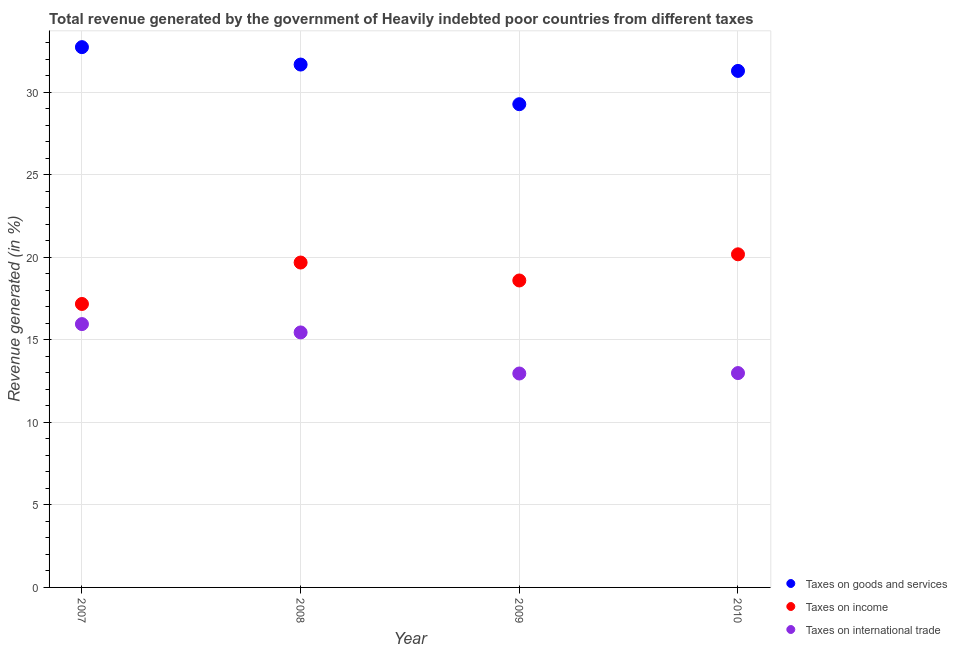Is the number of dotlines equal to the number of legend labels?
Your response must be concise. Yes. What is the percentage of revenue generated by taxes on goods and services in 2007?
Provide a succinct answer. 32.74. Across all years, what is the maximum percentage of revenue generated by taxes on goods and services?
Your response must be concise. 32.74. Across all years, what is the minimum percentage of revenue generated by taxes on goods and services?
Offer a very short reply. 29.28. What is the total percentage of revenue generated by tax on international trade in the graph?
Keep it short and to the point. 57.36. What is the difference between the percentage of revenue generated by tax on international trade in 2008 and that in 2009?
Keep it short and to the point. 2.49. What is the difference between the percentage of revenue generated by tax on international trade in 2010 and the percentage of revenue generated by taxes on goods and services in 2009?
Provide a short and direct response. -16.29. What is the average percentage of revenue generated by taxes on income per year?
Give a very brief answer. 18.91. In the year 2008, what is the difference between the percentage of revenue generated by taxes on goods and services and percentage of revenue generated by tax on international trade?
Your answer should be very brief. 16.23. What is the ratio of the percentage of revenue generated by tax on international trade in 2008 to that in 2010?
Keep it short and to the point. 1.19. What is the difference between the highest and the second highest percentage of revenue generated by tax on international trade?
Offer a terse response. 0.51. What is the difference between the highest and the lowest percentage of revenue generated by taxes on income?
Your answer should be very brief. 3.01. Is it the case that in every year, the sum of the percentage of revenue generated by taxes on goods and services and percentage of revenue generated by taxes on income is greater than the percentage of revenue generated by tax on international trade?
Ensure brevity in your answer.  Yes. Is the percentage of revenue generated by tax on international trade strictly greater than the percentage of revenue generated by taxes on income over the years?
Offer a terse response. No. Is the percentage of revenue generated by taxes on goods and services strictly less than the percentage of revenue generated by tax on international trade over the years?
Your answer should be compact. No. How many dotlines are there?
Ensure brevity in your answer.  3. How many years are there in the graph?
Offer a very short reply. 4. What is the difference between two consecutive major ticks on the Y-axis?
Offer a terse response. 5. Does the graph contain any zero values?
Keep it short and to the point. No. Does the graph contain grids?
Give a very brief answer. Yes. Where does the legend appear in the graph?
Offer a terse response. Bottom right. How are the legend labels stacked?
Ensure brevity in your answer.  Vertical. What is the title of the graph?
Make the answer very short. Total revenue generated by the government of Heavily indebted poor countries from different taxes. Does "Ages 65 and above" appear as one of the legend labels in the graph?
Provide a succinct answer. No. What is the label or title of the Y-axis?
Offer a very short reply. Revenue generated (in %). What is the Revenue generated (in %) of Taxes on goods and services in 2007?
Your answer should be compact. 32.74. What is the Revenue generated (in %) of Taxes on income in 2007?
Keep it short and to the point. 17.18. What is the Revenue generated (in %) in Taxes on international trade in 2007?
Offer a very short reply. 15.96. What is the Revenue generated (in %) of Taxes on goods and services in 2008?
Ensure brevity in your answer.  31.68. What is the Revenue generated (in %) of Taxes on income in 2008?
Your answer should be very brief. 19.69. What is the Revenue generated (in %) of Taxes on international trade in 2008?
Ensure brevity in your answer.  15.45. What is the Revenue generated (in %) in Taxes on goods and services in 2009?
Offer a terse response. 29.28. What is the Revenue generated (in %) in Taxes on income in 2009?
Offer a very short reply. 18.6. What is the Revenue generated (in %) in Taxes on international trade in 2009?
Offer a terse response. 12.96. What is the Revenue generated (in %) in Taxes on goods and services in 2010?
Your response must be concise. 31.3. What is the Revenue generated (in %) of Taxes on income in 2010?
Make the answer very short. 20.19. What is the Revenue generated (in %) in Taxes on international trade in 2010?
Offer a very short reply. 12.99. Across all years, what is the maximum Revenue generated (in %) of Taxes on goods and services?
Make the answer very short. 32.74. Across all years, what is the maximum Revenue generated (in %) in Taxes on income?
Provide a short and direct response. 20.19. Across all years, what is the maximum Revenue generated (in %) of Taxes on international trade?
Make the answer very short. 15.96. Across all years, what is the minimum Revenue generated (in %) of Taxes on goods and services?
Offer a terse response. 29.28. Across all years, what is the minimum Revenue generated (in %) in Taxes on income?
Your response must be concise. 17.18. Across all years, what is the minimum Revenue generated (in %) of Taxes on international trade?
Offer a terse response. 12.96. What is the total Revenue generated (in %) in Taxes on goods and services in the graph?
Offer a very short reply. 125. What is the total Revenue generated (in %) of Taxes on income in the graph?
Ensure brevity in your answer.  75.65. What is the total Revenue generated (in %) of Taxes on international trade in the graph?
Provide a succinct answer. 57.36. What is the difference between the Revenue generated (in %) in Taxes on goods and services in 2007 and that in 2008?
Your answer should be compact. 1.05. What is the difference between the Revenue generated (in %) in Taxes on income in 2007 and that in 2008?
Give a very brief answer. -2.51. What is the difference between the Revenue generated (in %) in Taxes on international trade in 2007 and that in 2008?
Provide a short and direct response. 0.51. What is the difference between the Revenue generated (in %) of Taxes on goods and services in 2007 and that in 2009?
Provide a succinct answer. 3.46. What is the difference between the Revenue generated (in %) in Taxes on income in 2007 and that in 2009?
Offer a very short reply. -1.42. What is the difference between the Revenue generated (in %) in Taxes on international trade in 2007 and that in 2009?
Give a very brief answer. 2.99. What is the difference between the Revenue generated (in %) of Taxes on goods and services in 2007 and that in 2010?
Make the answer very short. 1.44. What is the difference between the Revenue generated (in %) in Taxes on income in 2007 and that in 2010?
Your answer should be very brief. -3.01. What is the difference between the Revenue generated (in %) in Taxes on international trade in 2007 and that in 2010?
Keep it short and to the point. 2.97. What is the difference between the Revenue generated (in %) of Taxes on goods and services in 2008 and that in 2009?
Ensure brevity in your answer.  2.4. What is the difference between the Revenue generated (in %) of Taxes on income in 2008 and that in 2009?
Offer a very short reply. 1.09. What is the difference between the Revenue generated (in %) in Taxes on international trade in 2008 and that in 2009?
Your response must be concise. 2.49. What is the difference between the Revenue generated (in %) of Taxes on goods and services in 2008 and that in 2010?
Your response must be concise. 0.39. What is the difference between the Revenue generated (in %) in Taxes on income in 2008 and that in 2010?
Provide a short and direct response. -0.5. What is the difference between the Revenue generated (in %) in Taxes on international trade in 2008 and that in 2010?
Offer a very short reply. 2.46. What is the difference between the Revenue generated (in %) in Taxes on goods and services in 2009 and that in 2010?
Offer a terse response. -2.02. What is the difference between the Revenue generated (in %) of Taxes on income in 2009 and that in 2010?
Provide a short and direct response. -1.59. What is the difference between the Revenue generated (in %) of Taxes on international trade in 2009 and that in 2010?
Provide a succinct answer. -0.03. What is the difference between the Revenue generated (in %) in Taxes on goods and services in 2007 and the Revenue generated (in %) in Taxes on income in 2008?
Offer a very short reply. 13.05. What is the difference between the Revenue generated (in %) in Taxes on goods and services in 2007 and the Revenue generated (in %) in Taxes on international trade in 2008?
Keep it short and to the point. 17.29. What is the difference between the Revenue generated (in %) in Taxes on income in 2007 and the Revenue generated (in %) in Taxes on international trade in 2008?
Give a very brief answer. 1.73. What is the difference between the Revenue generated (in %) of Taxes on goods and services in 2007 and the Revenue generated (in %) of Taxes on income in 2009?
Your answer should be very brief. 14.14. What is the difference between the Revenue generated (in %) of Taxes on goods and services in 2007 and the Revenue generated (in %) of Taxes on international trade in 2009?
Keep it short and to the point. 19.78. What is the difference between the Revenue generated (in %) in Taxes on income in 2007 and the Revenue generated (in %) in Taxes on international trade in 2009?
Offer a terse response. 4.21. What is the difference between the Revenue generated (in %) of Taxes on goods and services in 2007 and the Revenue generated (in %) of Taxes on income in 2010?
Provide a succinct answer. 12.55. What is the difference between the Revenue generated (in %) in Taxes on goods and services in 2007 and the Revenue generated (in %) in Taxes on international trade in 2010?
Offer a terse response. 19.75. What is the difference between the Revenue generated (in %) of Taxes on income in 2007 and the Revenue generated (in %) of Taxes on international trade in 2010?
Provide a short and direct response. 4.19. What is the difference between the Revenue generated (in %) of Taxes on goods and services in 2008 and the Revenue generated (in %) of Taxes on income in 2009?
Your answer should be compact. 13.08. What is the difference between the Revenue generated (in %) in Taxes on goods and services in 2008 and the Revenue generated (in %) in Taxes on international trade in 2009?
Your answer should be compact. 18.72. What is the difference between the Revenue generated (in %) of Taxes on income in 2008 and the Revenue generated (in %) of Taxes on international trade in 2009?
Your response must be concise. 6.72. What is the difference between the Revenue generated (in %) in Taxes on goods and services in 2008 and the Revenue generated (in %) in Taxes on income in 2010?
Give a very brief answer. 11.5. What is the difference between the Revenue generated (in %) of Taxes on goods and services in 2008 and the Revenue generated (in %) of Taxes on international trade in 2010?
Offer a terse response. 18.69. What is the difference between the Revenue generated (in %) of Taxes on income in 2008 and the Revenue generated (in %) of Taxes on international trade in 2010?
Offer a very short reply. 6.7. What is the difference between the Revenue generated (in %) of Taxes on goods and services in 2009 and the Revenue generated (in %) of Taxes on income in 2010?
Offer a very short reply. 9.1. What is the difference between the Revenue generated (in %) in Taxes on goods and services in 2009 and the Revenue generated (in %) in Taxes on international trade in 2010?
Provide a succinct answer. 16.29. What is the difference between the Revenue generated (in %) in Taxes on income in 2009 and the Revenue generated (in %) in Taxes on international trade in 2010?
Keep it short and to the point. 5.61. What is the average Revenue generated (in %) of Taxes on goods and services per year?
Keep it short and to the point. 31.25. What is the average Revenue generated (in %) in Taxes on income per year?
Offer a terse response. 18.91. What is the average Revenue generated (in %) of Taxes on international trade per year?
Provide a succinct answer. 14.34. In the year 2007, what is the difference between the Revenue generated (in %) of Taxes on goods and services and Revenue generated (in %) of Taxes on income?
Keep it short and to the point. 15.56. In the year 2007, what is the difference between the Revenue generated (in %) of Taxes on goods and services and Revenue generated (in %) of Taxes on international trade?
Keep it short and to the point. 16.78. In the year 2007, what is the difference between the Revenue generated (in %) in Taxes on income and Revenue generated (in %) in Taxes on international trade?
Provide a short and direct response. 1.22. In the year 2008, what is the difference between the Revenue generated (in %) of Taxes on goods and services and Revenue generated (in %) of Taxes on income?
Provide a succinct answer. 12. In the year 2008, what is the difference between the Revenue generated (in %) in Taxes on goods and services and Revenue generated (in %) in Taxes on international trade?
Provide a succinct answer. 16.23. In the year 2008, what is the difference between the Revenue generated (in %) in Taxes on income and Revenue generated (in %) in Taxes on international trade?
Keep it short and to the point. 4.24. In the year 2009, what is the difference between the Revenue generated (in %) of Taxes on goods and services and Revenue generated (in %) of Taxes on income?
Make the answer very short. 10.68. In the year 2009, what is the difference between the Revenue generated (in %) of Taxes on goods and services and Revenue generated (in %) of Taxes on international trade?
Make the answer very short. 16.32. In the year 2009, what is the difference between the Revenue generated (in %) in Taxes on income and Revenue generated (in %) in Taxes on international trade?
Ensure brevity in your answer.  5.64. In the year 2010, what is the difference between the Revenue generated (in %) of Taxes on goods and services and Revenue generated (in %) of Taxes on income?
Keep it short and to the point. 11.11. In the year 2010, what is the difference between the Revenue generated (in %) of Taxes on goods and services and Revenue generated (in %) of Taxes on international trade?
Provide a succinct answer. 18.31. In the year 2010, what is the difference between the Revenue generated (in %) in Taxes on income and Revenue generated (in %) in Taxes on international trade?
Make the answer very short. 7.2. What is the ratio of the Revenue generated (in %) in Taxes on income in 2007 to that in 2008?
Provide a short and direct response. 0.87. What is the ratio of the Revenue generated (in %) in Taxes on international trade in 2007 to that in 2008?
Make the answer very short. 1.03. What is the ratio of the Revenue generated (in %) in Taxes on goods and services in 2007 to that in 2009?
Your answer should be compact. 1.12. What is the ratio of the Revenue generated (in %) in Taxes on income in 2007 to that in 2009?
Provide a succinct answer. 0.92. What is the ratio of the Revenue generated (in %) of Taxes on international trade in 2007 to that in 2009?
Offer a terse response. 1.23. What is the ratio of the Revenue generated (in %) of Taxes on goods and services in 2007 to that in 2010?
Your answer should be very brief. 1.05. What is the ratio of the Revenue generated (in %) of Taxes on income in 2007 to that in 2010?
Your answer should be very brief. 0.85. What is the ratio of the Revenue generated (in %) of Taxes on international trade in 2007 to that in 2010?
Your answer should be very brief. 1.23. What is the ratio of the Revenue generated (in %) in Taxes on goods and services in 2008 to that in 2009?
Give a very brief answer. 1.08. What is the ratio of the Revenue generated (in %) of Taxes on income in 2008 to that in 2009?
Your answer should be very brief. 1.06. What is the ratio of the Revenue generated (in %) of Taxes on international trade in 2008 to that in 2009?
Keep it short and to the point. 1.19. What is the ratio of the Revenue generated (in %) in Taxes on goods and services in 2008 to that in 2010?
Provide a short and direct response. 1.01. What is the ratio of the Revenue generated (in %) in Taxes on income in 2008 to that in 2010?
Provide a succinct answer. 0.98. What is the ratio of the Revenue generated (in %) in Taxes on international trade in 2008 to that in 2010?
Provide a short and direct response. 1.19. What is the ratio of the Revenue generated (in %) in Taxes on goods and services in 2009 to that in 2010?
Provide a short and direct response. 0.94. What is the ratio of the Revenue generated (in %) in Taxes on income in 2009 to that in 2010?
Ensure brevity in your answer.  0.92. What is the ratio of the Revenue generated (in %) in Taxes on international trade in 2009 to that in 2010?
Give a very brief answer. 1. What is the difference between the highest and the second highest Revenue generated (in %) of Taxes on goods and services?
Keep it short and to the point. 1.05. What is the difference between the highest and the second highest Revenue generated (in %) of Taxes on income?
Ensure brevity in your answer.  0.5. What is the difference between the highest and the second highest Revenue generated (in %) in Taxes on international trade?
Offer a terse response. 0.51. What is the difference between the highest and the lowest Revenue generated (in %) of Taxes on goods and services?
Your answer should be compact. 3.46. What is the difference between the highest and the lowest Revenue generated (in %) of Taxes on income?
Your response must be concise. 3.01. What is the difference between the highest and the lowest Revenue generated (in %) in Taxes on international trade?
Give a very brief answer. 2.99. 